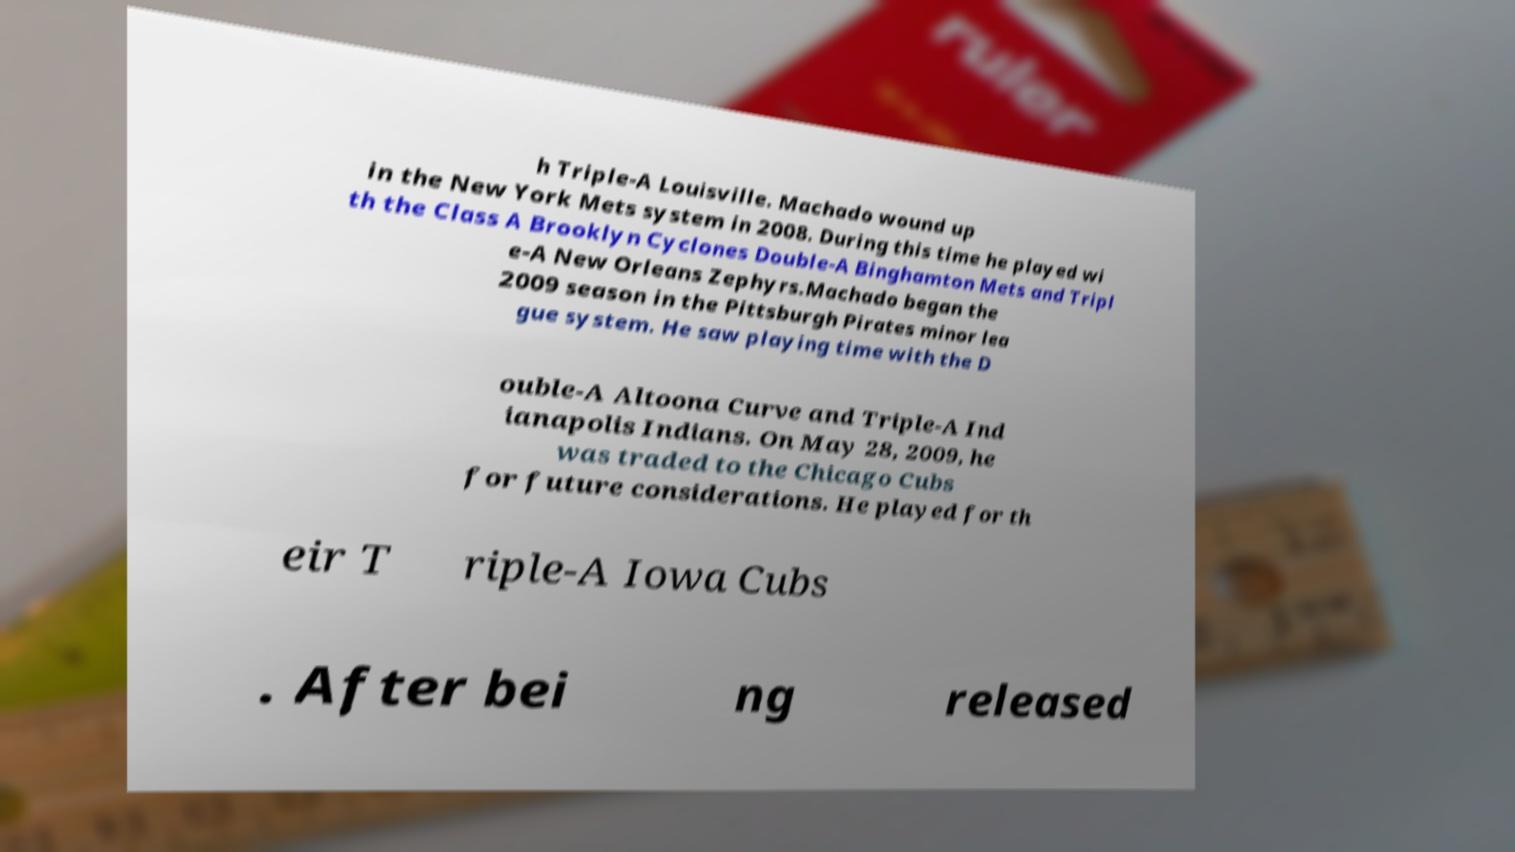Can you read and provide the text displayed in the image?This photo seems to have some interesting text. Can you extract and type it out for me? h Triple-A Louisville. Machado wound up in the New York Mets system in 2008. During this time he played wi th the Class A Brooklyn Cyclones Double-A Binghamton Mets and Tripl e-A New Orleans Zephyrs.Machado began the 2009 season in the Pittsburgh Pirates minor lea gue system. He saw playing time with the D ouble-A Altoona Curve and Triple-A Ind ianapolis Indians. On May 28, 2009, he was traded to the Chicago Cubs for future considerations. He played for th eir T riple-A Iowa Cubs . After bei ng released 